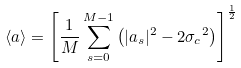<formula> <loc_0><loc_0><loc_500><loc_500>\langle a \rangle = \left [ \frac { 1 } { M } \sum _ { s = 0 } ^ { M - 1 } \left ( | a _ { s } | ^ { 2 } - 2 { \sigma _ { c } } ^ { 2 } \right ) \right ] ^ { \frac { 1 } { 2 } }</formula> 